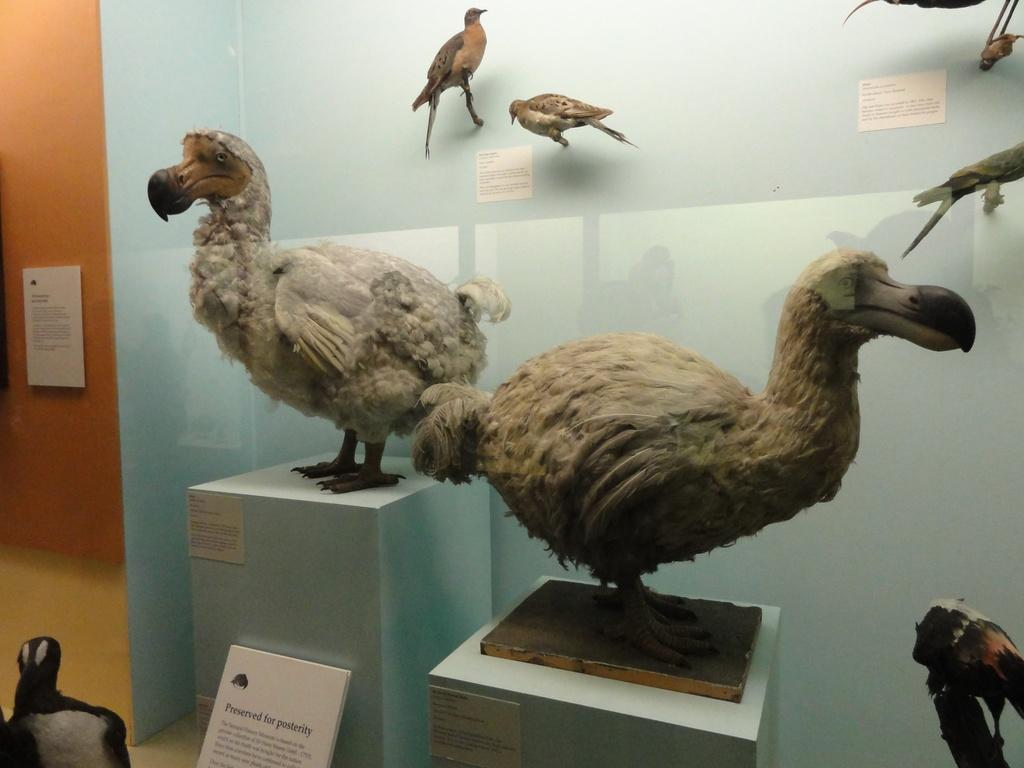What type of animals can be seen in the image? There are birds in the image. How are the birds positioned in the image? The birds are on wooden sticks and surfaces. What are the birds resting on in the image? The birds are on boards. What can be seen in the background of the image? There is a wall visible in the background of the image. What type of produce is being harvested by the company in the image? There is no company or produce present in the image; it features birds on wooden sticks and surfaces. What is the cause of the thunder in the image? There is no thunder present in the image; it features birds on wooden sticks and surfaces. 